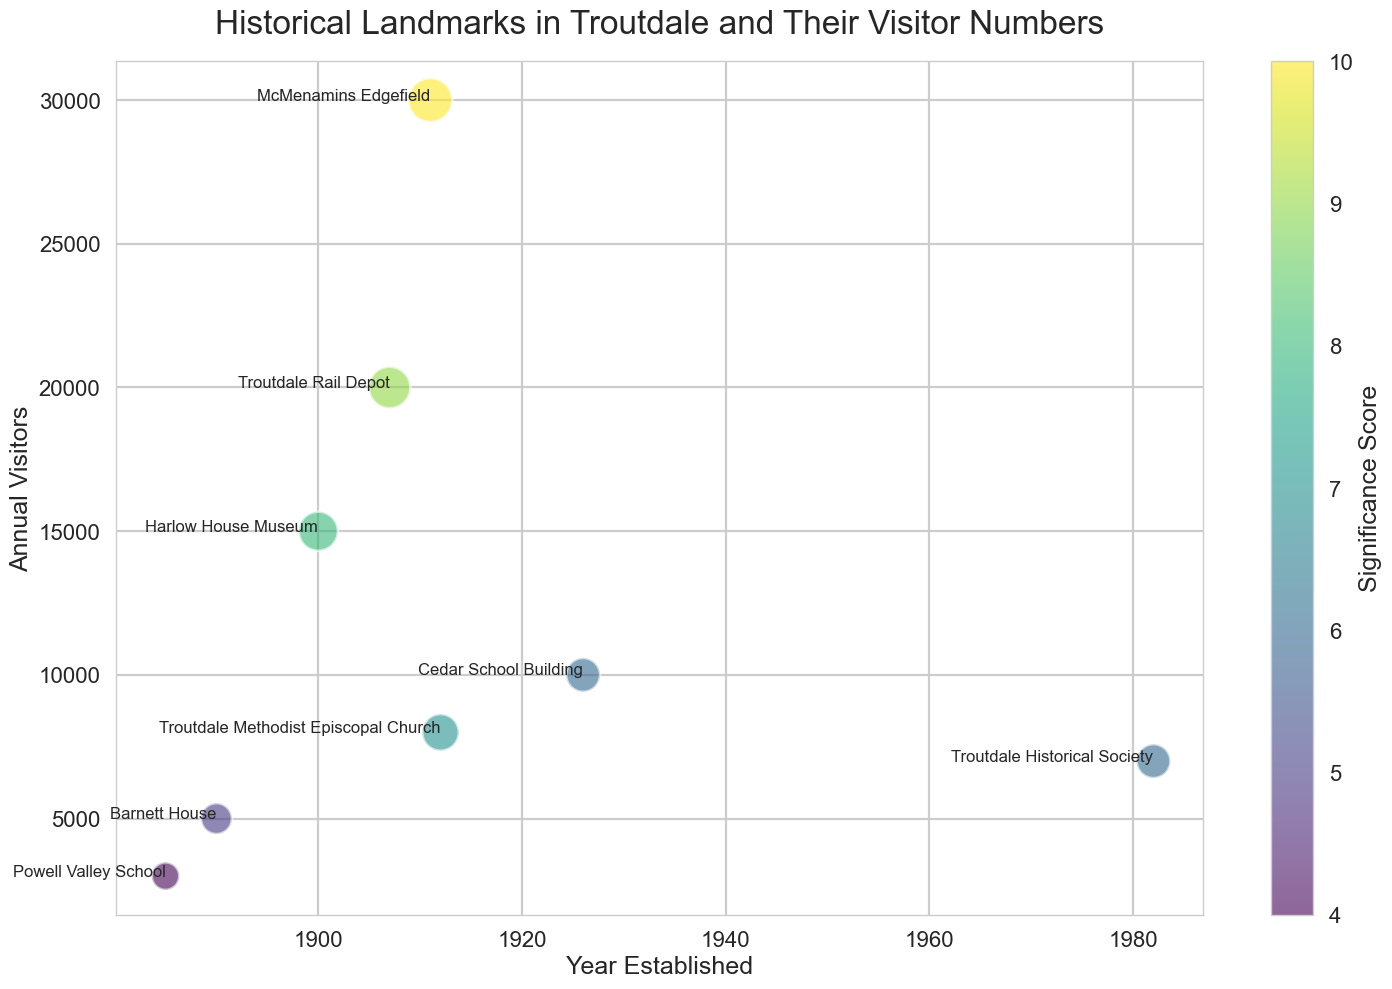Which historical landmark in Troutdale has the highest annual visitors? The highest bubble on the number-of-visitors axis represents McMenamins Edgefield, so it has the highest annual visitors.
Answer: McMenamins Edgefield Which historical landmark was established first? On the horizontal axis for Year Established, the oldest (leftmost) bubble represents Powell Valley School, indicating it was established first.
Answer: Powell Valley School Which landmark has a higher significance score, Harlow House Museum or Cedar School Building? Harlow House Museum is marked with a higher color intensity compared to Cedar School Building, indicating a higher significance score.
Answer: Harlow House Museum What is the total number of annual visitors for all landmarks established after 1900? Add up the visitors for all landmarks established after 1900: Cedar School Building (10,000), Troutdale Methodist Episcopal Church (8,000), Troutdale Rail Depot (20,000), McMenamins Edgefield (30,000), and Troutdale Historical Society (7,000): 10,000 + 8,000 + 20,000 + 30,000 + 7,000 = 75,000
Answer: 75,000 Which landmark has the smallest significance score, and how many visitors does it get annually? The least intense (lightest) bubble represents Powell Valley School with the smallest significance score; looking at its size on the visitor axis indicates 3,000 annual visitors.
Answer: Powell Valley School, 3,000 Compare the annual visitors of Barnett House and Troutdale Methodist Episcopal Church. Which one receives more visitors? Comparing the vertical position of the bubbles for both landmarks, the bubble representing Troutdale Methodist Episcopal Church is higher, indicating more visitors compared to Barnett House.
Answer: Troutdale Methodist Episcopal Church What is the average annual visitor number for all landmarks with a significance score of 6? From the figure, identify landmarks with a significance score of 6: Cedar School Building (10,000 visitors), and Troutdale Historical Society (7,000 visitors); the average is calculated as (10,000 + 7,000) / 2 = 8,500
Answer: 8,500 Which landmark established in the 1900s has the highest significance score? For landmarks established in the 1900s, compare their significance scores: Harlow House Museum (8), Troutdale Methodist Episcopal Church (7), Troutdale Rail Depot (9), McMenamins Edgefield (10). The highest is McMenamins Edgefield.
Answer: McMenamins Edgefield Which two landmarks established before 1900 have the largest difference in annual visitors, and what is that difference? Compare the visitors for landmarks established before 1900: Barnett House (5,000) and Powell Valley School (3,000) with Harlow House Museum (15,000). The largest difference is between Powell Valley School and Harlow House Museum: 15,000 - 3,000 = 12,000
Answer: Harlow House Museum and Powell Valley School, 12,000 